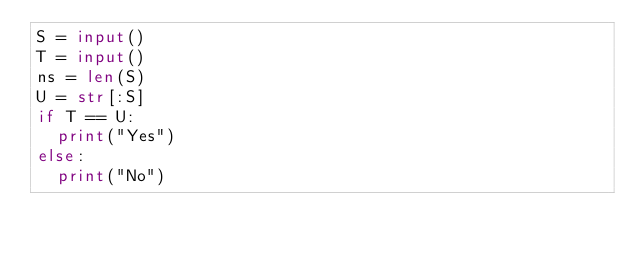<code> <loc_0><loc_0><loc_500><loc_500><_Python_>S = input()
T = input()
ns = len(S)
U = str[:S]
if T == U:
  print("Yes")
else:
  print("No")</code> 